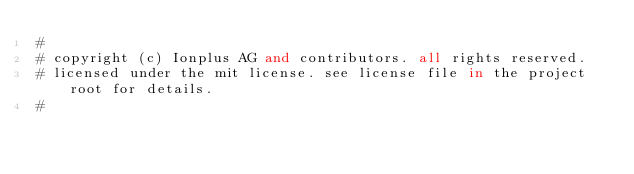<code> <loc_0><loc_0><loc_500><loc_500><_SQL_>#
# copyright (c) Ionplus AG and contributors. all rights reserved.
# licensed under the mit license. see license file in the project root for details.
#
</code> 